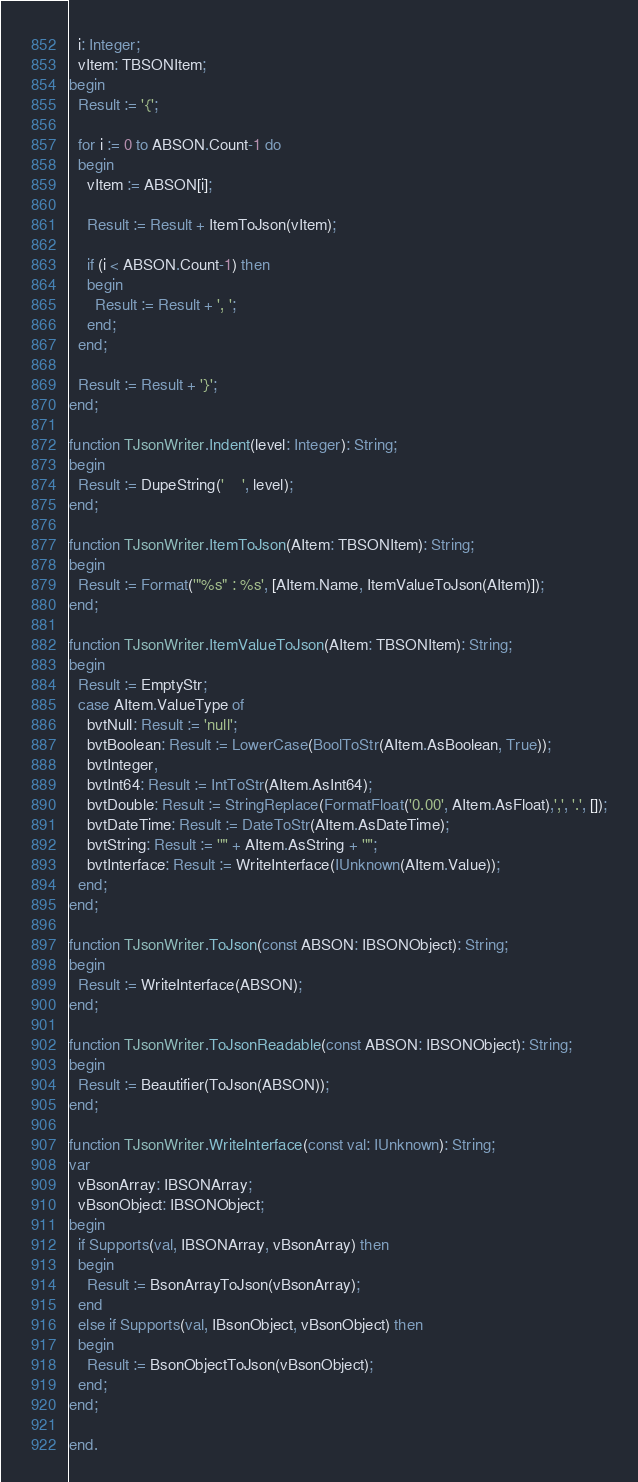<code> <loc_0><loc_0><loc_500><loc_500><_Pascal_>  i: Integer;
  vItem: TBSONItem;
begin
  Result := '{';

  for i := 0 to ABSON.Count-1 do
  begin
    vItem := ABSON[i];

    Result := Result + ItemToJson(vItem);

    if (i < ABSON.Count-1) then
    begin
      Result := Result + ', ';
    end;
  end;

  Result := Result + '}';
end;

function TJsonWriter.Indent(level: Integer): String;
begin
  Result := DupeString('    ', level);
end;

function TJsonWriter.ItemToJson(AItem: TBSONItem): String;
begin
  Result := Format('"%s" : %s', [AItem.Name, ItemValueToJson(AItem)]);
end;

function TJsonWriter.ItemValueToJson(AItem: TBSONItem): String;
begin
  Result := EmptyStr;
  case AItem.ValueType of
    bvtNull: Result := 'null';
    bvtBoolean: Result := LowerCase(BoolToStr(AItem.AsBoolean, True));
    bvtInteger,
    bvtInt64: Result := IntToStr(AItem.AsInt64);
    bvtDouble: Result := StringReplace(FormatFloat('0.00', AItem.AsFloat),',', '.', []);
    bvtDateTime: Result := DateToStr(AItem.AsDateTime);
    bvtString: Result := '"' + AItem.AsString + '"';
    bvtInterface: Result := WriteInterface(IUnknown(AItem.Value));
  end;
end;

function TJsonWriter.ToJson(const ABSON: IBSONObject): String;
begin
  Result := WriteInterface(ABSON);
end;

function TJsonWriter.ToJsonReadable(const ABSON: IBSONObject): String;
begin
  Result := Beautifier(ToJson(ABSON));
end;

function TJsonWriter.WriteInterface(const val: IUnknown): String;
var
  vBsonArray: IBSONArray;
  vBsonObject: IBSONObject;
begin
  if Supports(val, IBSONArray, vBsonArray) then
  begin
    Result := BsonArrayToJson(vBsonArray);
  end
  else if Supports(val, IBsonObject, vBsonObject) then
  begin
    Result := BsonObjectToJson(vBsonObject);
  end;
end;

end.
</code> 